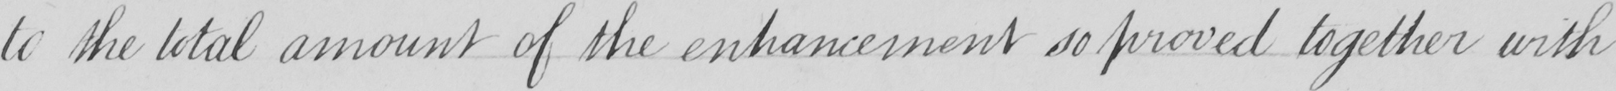What does this handwritten line say? to the total amount of the enhancement so proved together with 